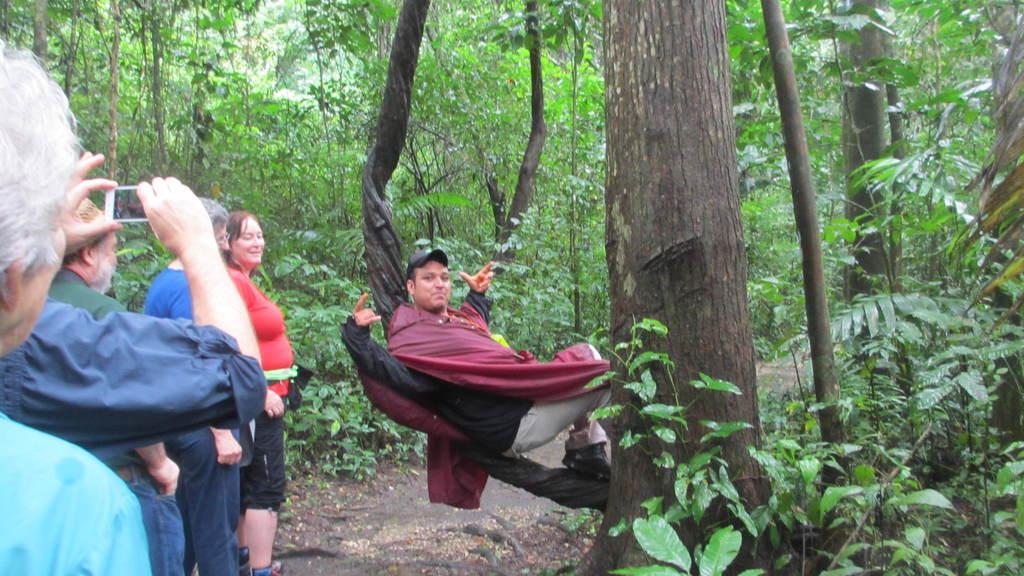Can you describe this image briefly? In the center of the image, we can see a man lying on the tree and on the left, there are some people standing and one of them is holding mobile. In the background, there are many trees. 